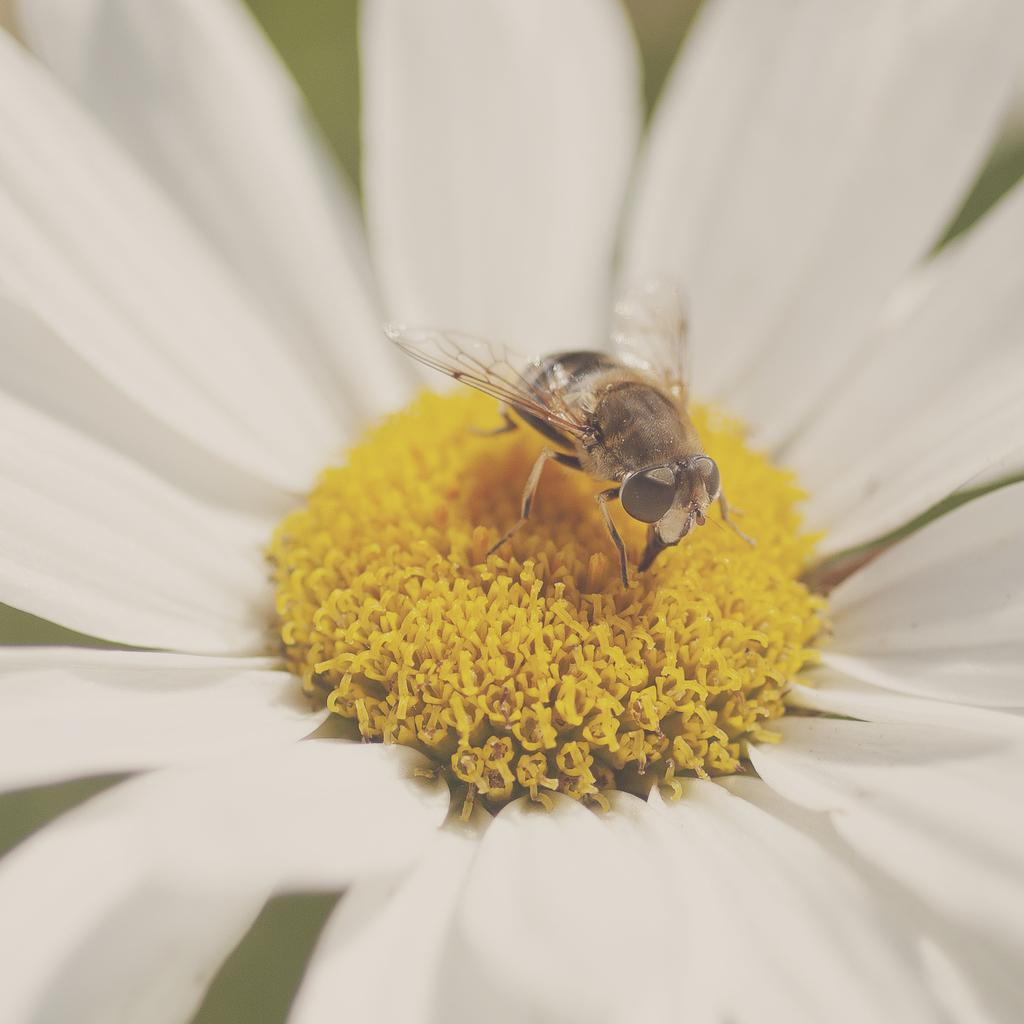What is on the flower in the image? There is an insect on the flower in the image. What color is the flower? The flower is white. What color is the background of the image? The background of the image is light green. What type of bucket is being used by the team on the stage in the image? There is no bucket, team, or stage present in the image. 